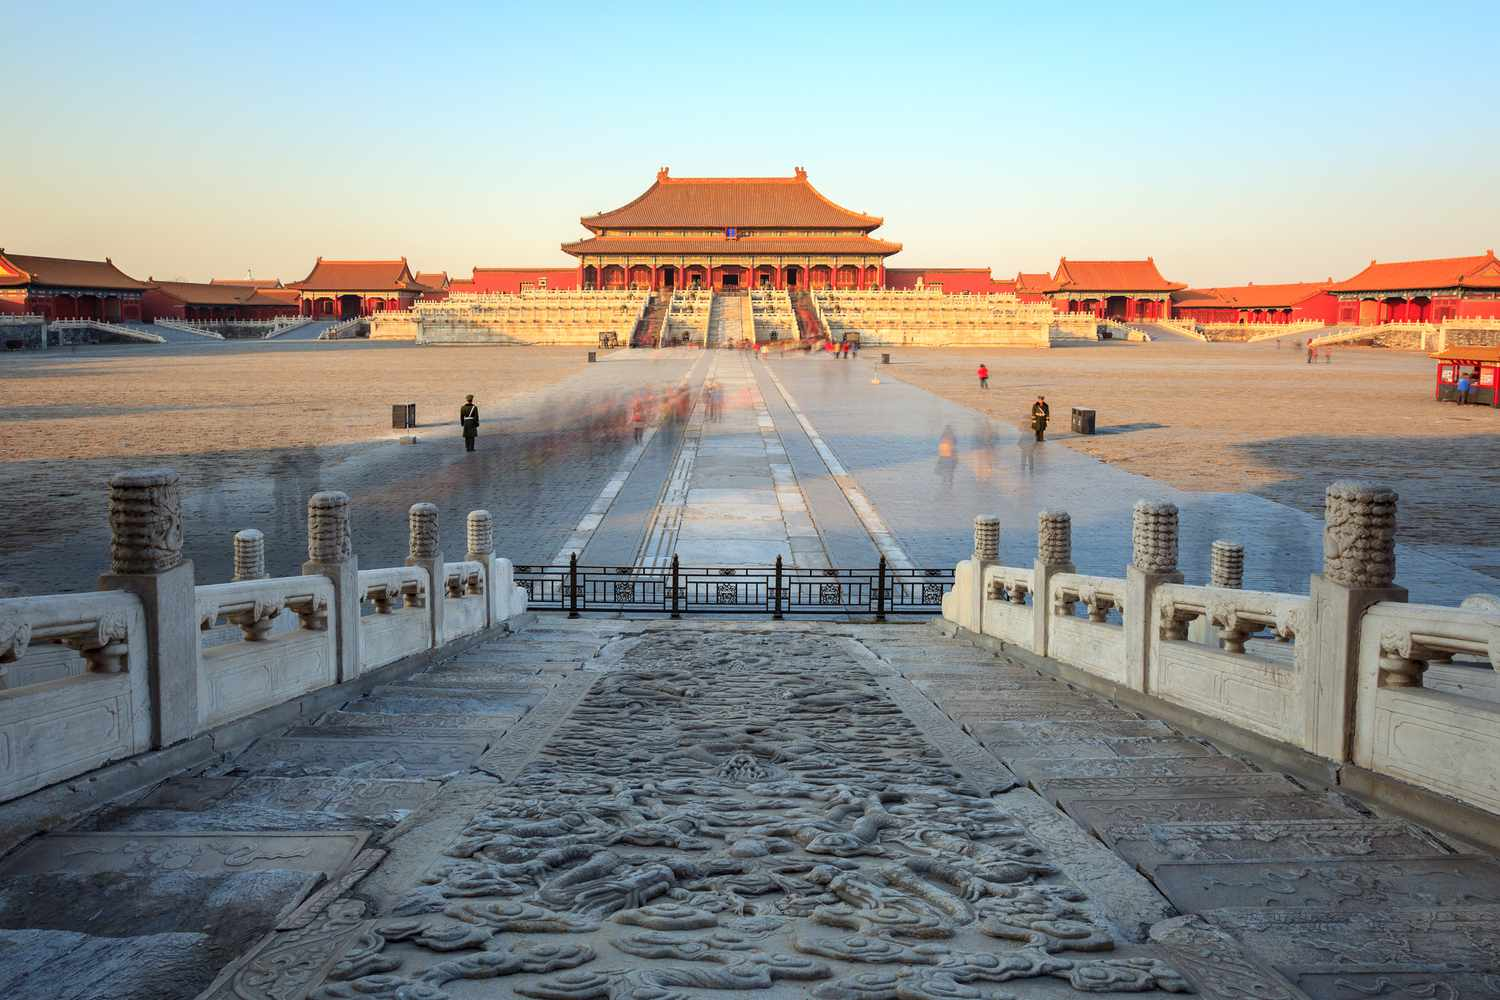Could you describe the historical significance of this place? The Forbidden City, located in the heart of Beijing, served as the imperial palace for 24 emperors of the Ming and Qing dynasties. Constructed from 1406 to 1420, it is the largest ancient palatial structure in the world. The palace complex, which includes approximately 980 surviving buildings and covers around 180 acres, was the political heart and ceremonial center of Chinese government for nearly 500 years. Today, the Forbidden City is a UNESCO World Heritage Site, drawing millions of visitors annually who come to marvel at its historical and architectural splendor. What unique architectural features does the Forbidden City have? The Forbidden City is renowned for its cohesive and grandiose architectural style, which reflects the traditional Chinese palatial structures. Noteworthy features include the use of red and yellow as dominant colors—red for walls and gates symbolizing national strength, and yellow for roofs representing royal sovereignty. The buildings are adorned with elaborate and colorful glazed tiles, detailed wooden carvings, and ornate stonework. One unique element is the symmetrical design, with the central axis running from north to south, delineating the layout of the city. The Hall of Supreme Harmony, the largest hall, served as the emperor's throne room and is a masterpiece of wooden architecture. Additionally, the complex is protected by a surrounding moat and high walls, emphasising its exclusivity and fortification. 